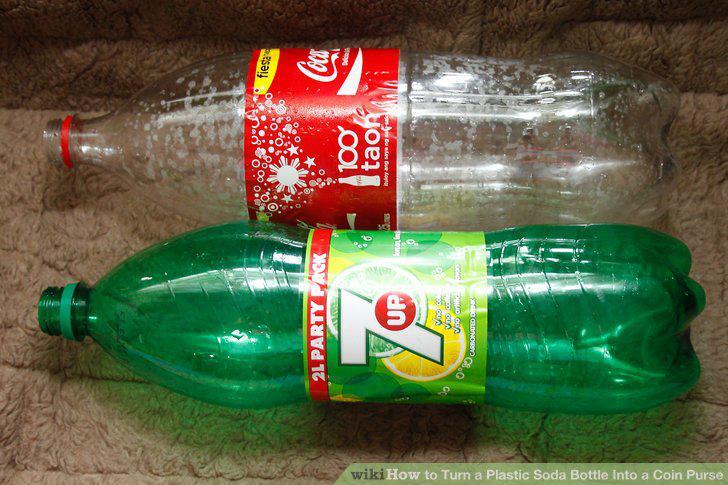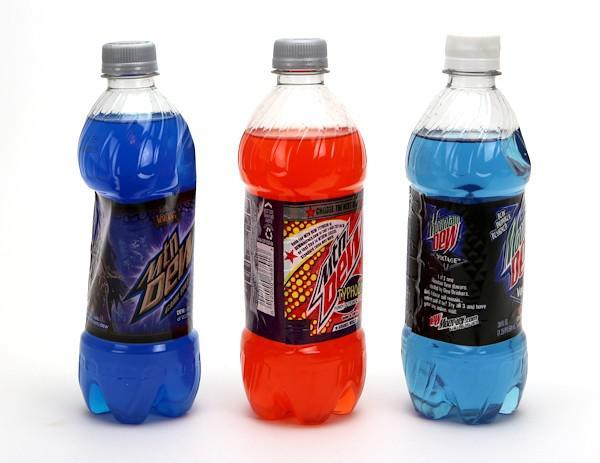The first image is the image on the left, the second image is the image on the right. For the images shown, is this caption "There are at least seven bottles in total." true? Answer yes or no. No. The first image is the image on the left, the second image is the image on the right. Evaluate the accuracy of this statement regarding the images: "All bottles are displayed upright, some bottles are not touching another bottle, and all bottles have printed labels on them.". Is it true? Answer yes or no. No. 